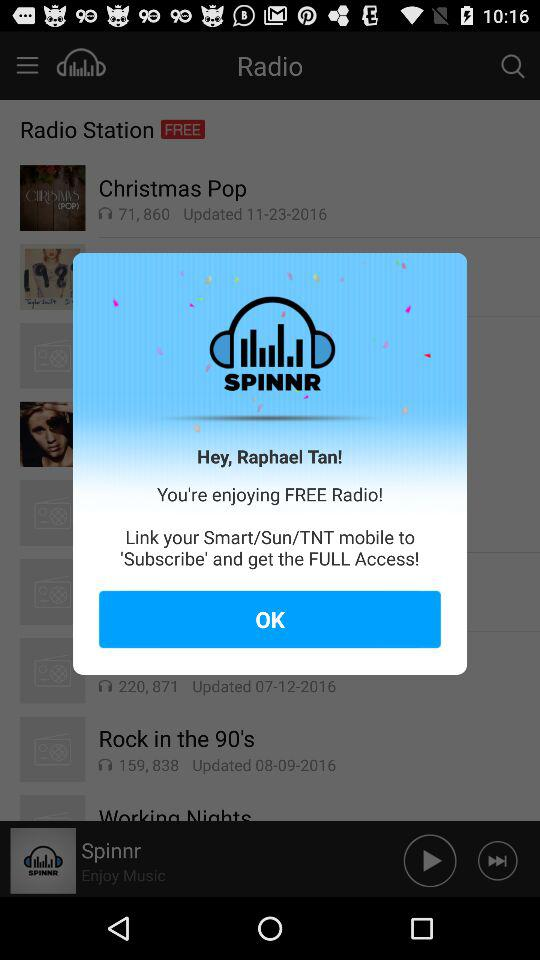What's the user name? The user name is Raphael Tan. 